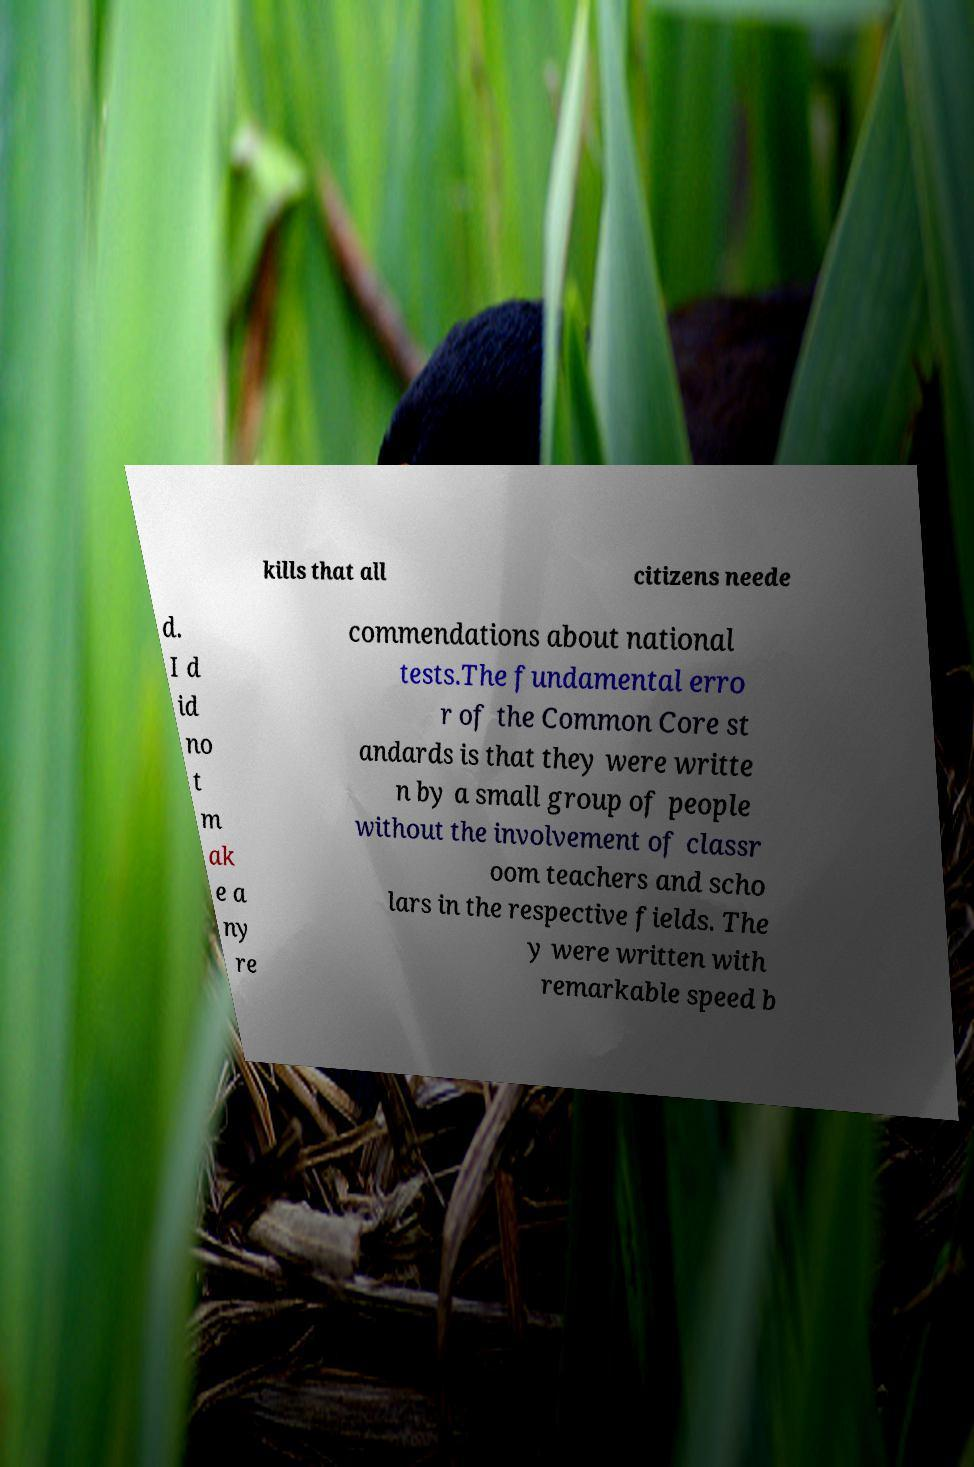Please read and relay the text visible in this image. What does it say? kills that all citizens neede d. I d id no t m ak e a ny re commendations about national tests.The fundamental erro r of the Common Core st andards is that they were writte n by a small group of people without the involvement of classr oom teachers and scho lars in the respective fields. The y were written with remarkable speed b 